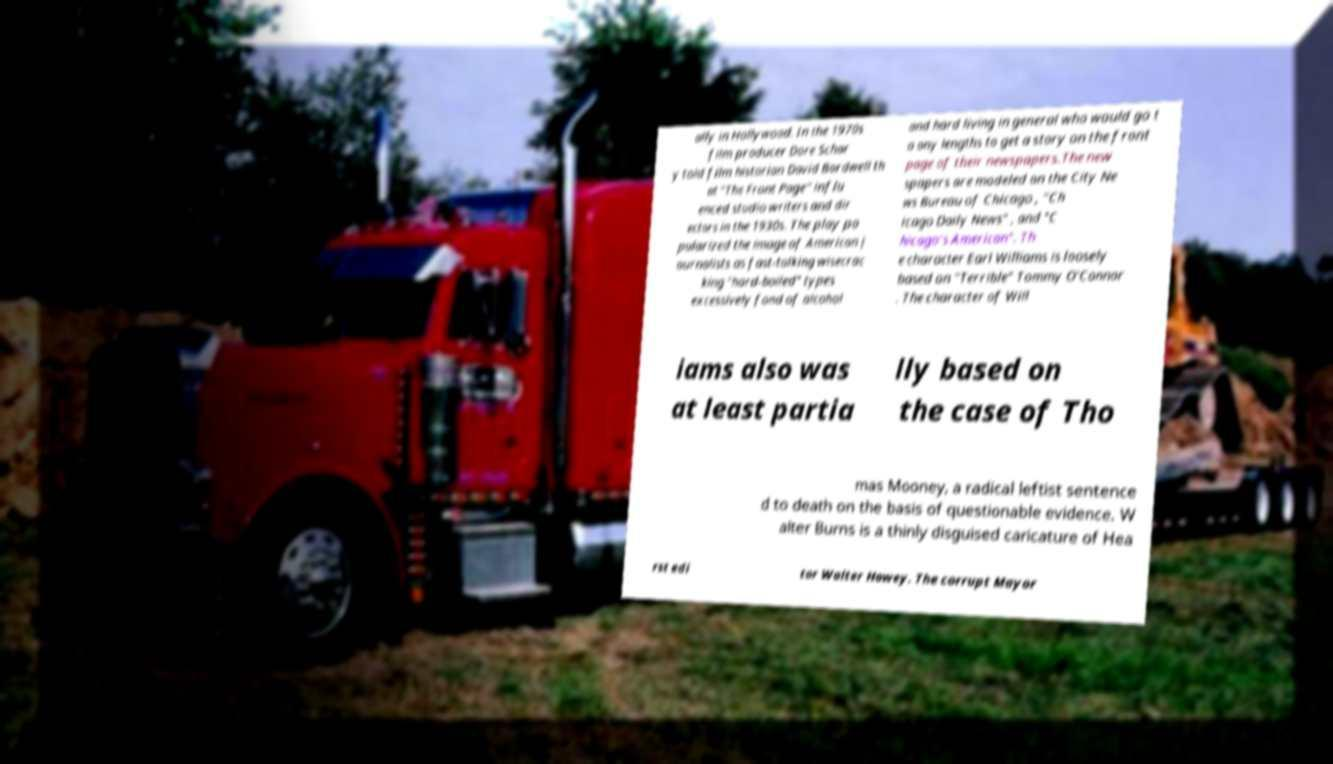There's text embedded in this image that I need extracted. Can you transcribe it verbatim? ally in Hollywood. In the 1970s film producer Dore Schar y told film historian David Bordwell th at "The Front Page" influ enced studio writers and dir ectors in the 1930s. The play po pularized the image of American j ournalists as fast-talking wisecrac king "hard-boiled" types excessively fond of alcohol and hard living in general who would go t o any lengths to get a story on the front page of their newspapers.The new spapers are modeled on the City Ne ws Bureau of Chicago , "Ch icago Daily News" , and "C hicago's American". Th e character Earl Williams is loosely based on "Terrible" Tommy O'Connor . The character of Will iams also was at least partia lly based on the case of Tho mas Mooney, a radical leftist sentence d to death on the basis of questionable evidence. W alter Burns is a thinly disguised caricature of Hea rst edi tor Walter Howey. The corrupt Mayor 